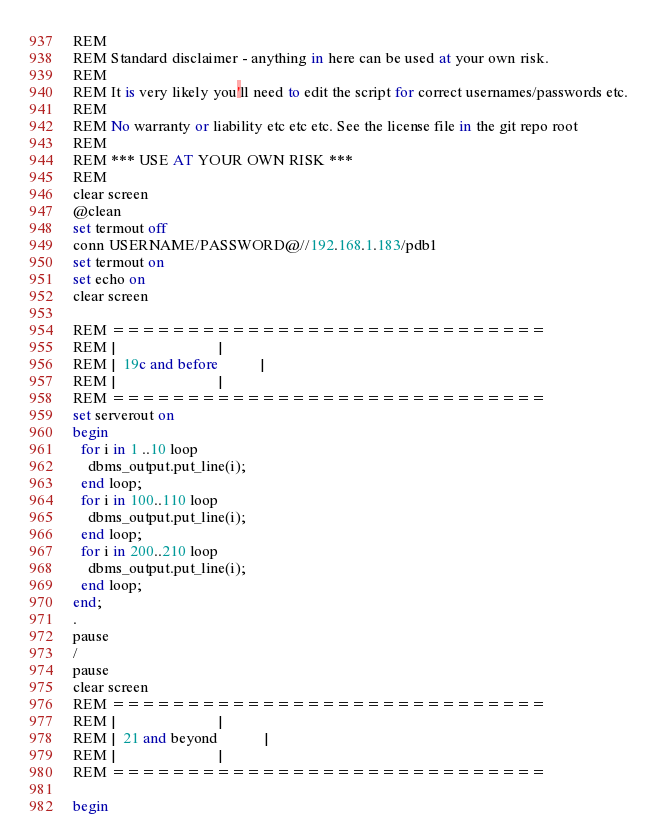Convert code to text. <code><loc_0><loc_0><loc_500><loc_500><_SQL_>REM
REM Standard disclaimer - anything in here can be used at your own risk.
REM 
REM It is very likely you'll need to edit the script for correct usernames/passwords etc.
REM 
REM No warranty or liability etc etc etc. See the license file in the git repo root
REM
REM *** USE AT YOUR OWN RISK ***
REM 
clear screen
@clean
set termout off
conn USERNAME/PASSWORD@//192.168.1.183/pdb1
set termout on
set echo on
clear screen

REM =============================
REM |                           |
REM |  19c and before           |
REM |                           |
REM =============================
set serverout on
begin
  for i in 1 ..10 loop
    dbms_output.put_line(i);
  end loop;
  for i in 100..110 loop
    dbms_output.put_line(i);
  end loop;
  for i in 200..210 loop
    dbms_output.put_line(i);
  end loop;
end;
.
pause
/
pause
clear screen
REM =============================
REM |                           |
REM |  21 and beyond            |
REM |                           |
REM =============================

begin</code> 